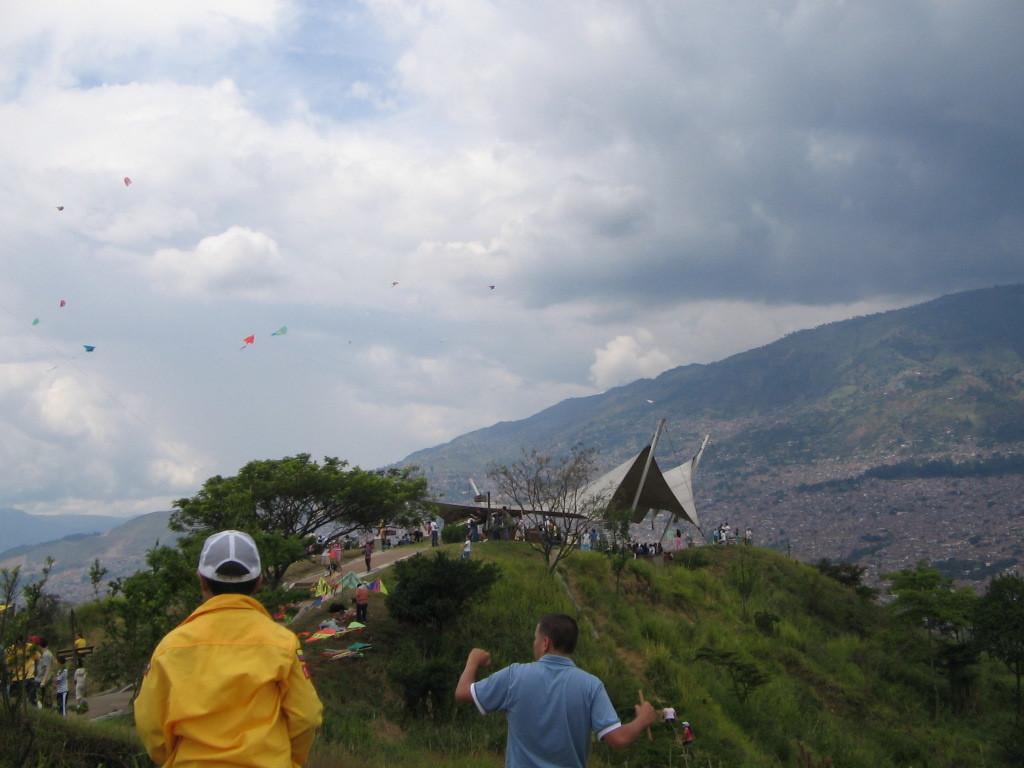Please provide a concise description of this image. In the foreground of the image there are two people. In the background of the image there is a mountain. There are trees. There are people standing. In the background of the image there are kites, sky and clouds. 